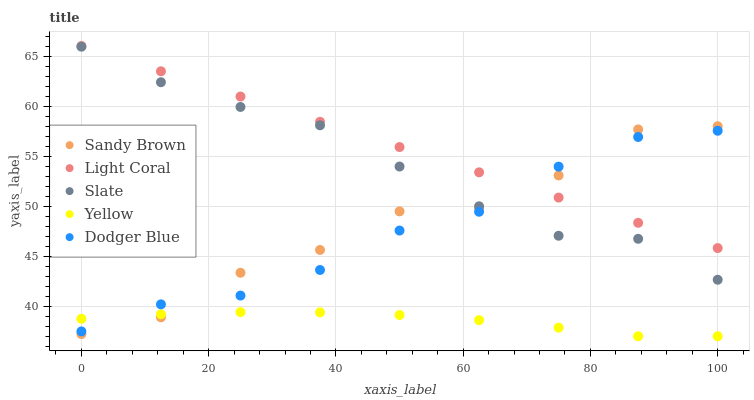Does Yellow have the minimum area under the curve?
Answer yes or no. Yes. Does Light Coral have the maximum area under the curve?
Answer yes or no. Yes. Does Dodger Blue have the minimum area under the curve?
Answer yes or no. No. Does Dodger Blue have the maximum area under the curve?
Answer yes or no. No. Is Light Coral the smoothest?
Answer yes or no. Yes. Is Sandy Brown the roughest?
Answer yes or no. Yes. Is Dodger Blue the smoothest?
Answer yes or no. No. Is Dodger Blue the roughest?
Answer yes or no. No. Does Yellow have the lowest value?
Answer yes or no. Yes. Does Dodger Blue have the lowest value?
Answer yes or no. No. Does Light Coral have the highest value?
Answer yes or no. Yes. Does Dodger Blue have the highest value?
Answer yes or no. No. Is Yellow less than Slate?
Answer yes or no. Yes. Is Slate greater than Yellow?
Answer yes or no. Yes. Does Yellow intersect Sandy Brown?
Answer yes or no. Yes. Is Yellow less than Sandy Brown?
Answer yes or no. No. Is Yellow greater than Sandy Brown?
Answer yes or no. No. Does Yellow intersect Slate?
Answer yes or no. No. 